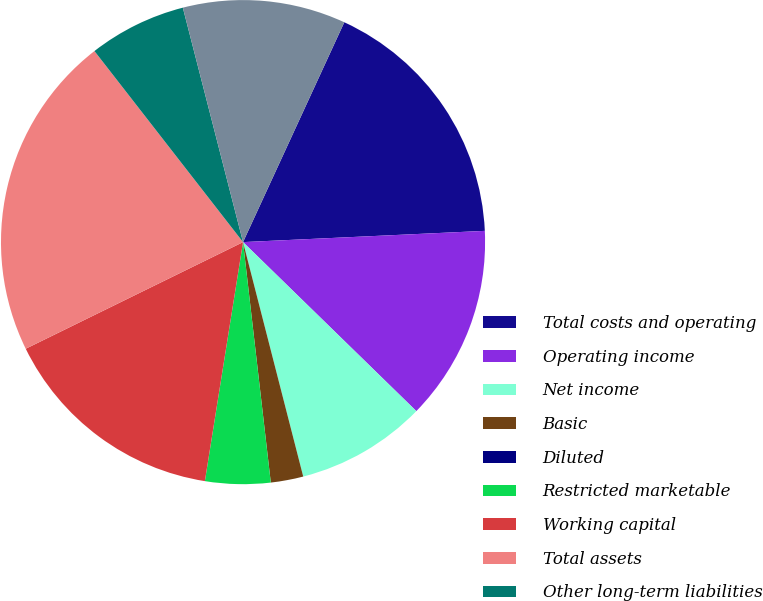Convert chart to OTSL. <chart><loc_0><loc_0><loc_500><loc_500><pie_chart><fcel>Total costs and operating<fcel>Operating income<fcel>Net income<fcel>Basic<fcel>Diluted<fcel>Restricted marketable<fcel>Working capital<fcel>Total assets<fcel>Other long-term liabilities<fcel>1 convertible senior notes<nl><fcel>17.39%<fcel>13.04%<fcel>8.7%<fcel>2.17%<fcel>0.0%<fcel>4.35%<fcel>15.22%<fcel>21.74%<fcel>6.52%<fcel>10.87%<nl></chart> 